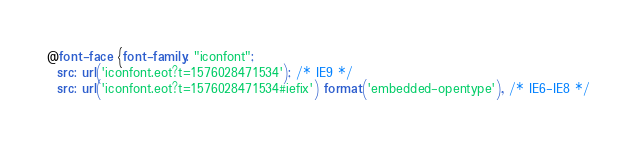Convert code to text. <code><loc_0><loc_0><loc_500><loc_500><_CSS_>@font-face {font-family: "iconfont";
  src: url('iconfont.eot?t=1576028471534'); /* IE9 */
  src: url('iconfont.eot?t=1576028471534#iefix') format('embedded-opentype'), /* IE6-IE8 */</code> 